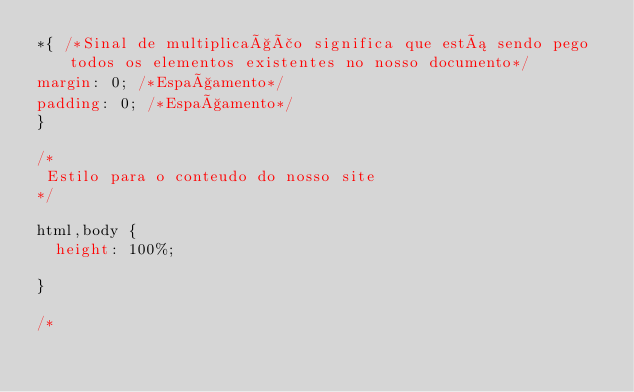Convert code to text. <code><loc_0><loc_0><loc_500><loc_500><_CSS_>*{ /*Sinal de multiplicação significa que está sendo pego todos os elementos existentes no nosso documento*/
margin: 0; /*Espaçamento*/
padding: 0; /*Espaçamento*/
}

/*
 Estilo para o conteudo do nosso site
*/

html,body {
	height: 100%;

}

/*</code> 